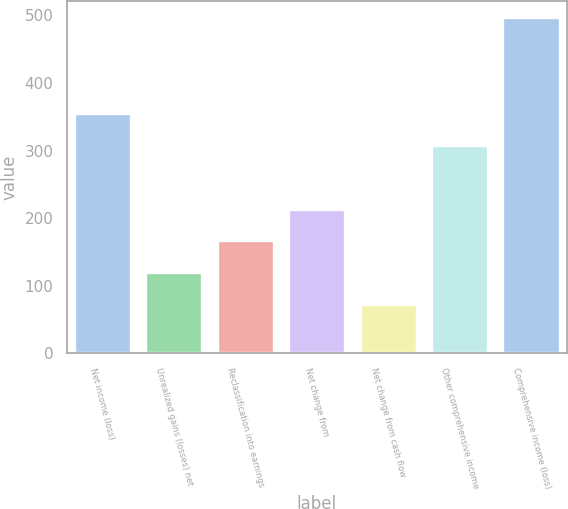Convert chart to OTSL. <chart><loc_0><loc_0><loc_500><loc_500><bar_chart><fcel>Net income (loss)<fcel>Unrealized gains (losses) net<fcel>Reclassification into earnings<fcel>Net change from<fcel>Net change from cash flow<fcel>Other comprehensive income<fcel>Comprehensive income (loss)<nl><fcel>355.7<fcel>120.2<fcel>167.3<fcel>214.4<fcel>73.1<fcel>308.6<fcel>497<nl></chart> 